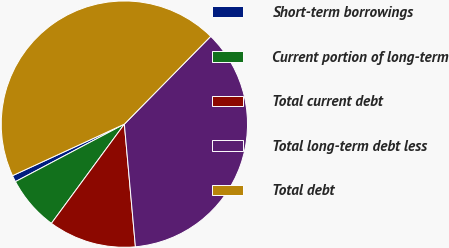Convert chart to OTSL. <chart><loc_0><loc_0><loc_500><loc_500><pie_chart><fcel>Short-term borrowings<fcel>Current portion of long-term<fcel>Total current debt<fcel>Total long-term debt less<fcel>Total debt<nl><fcel>0.86%<fcel>7.18%<fcel>11.52%<fcel>36.2%<fcel>44.24%<nl></chart> 